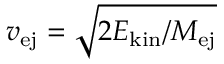Convert formula to latex. <formula><loc_0><loc_0><loc_500><loc_500>v _ { e j } = \sqrt { 2 E _ { k i n } / { M _ { e j } } }</formula> 